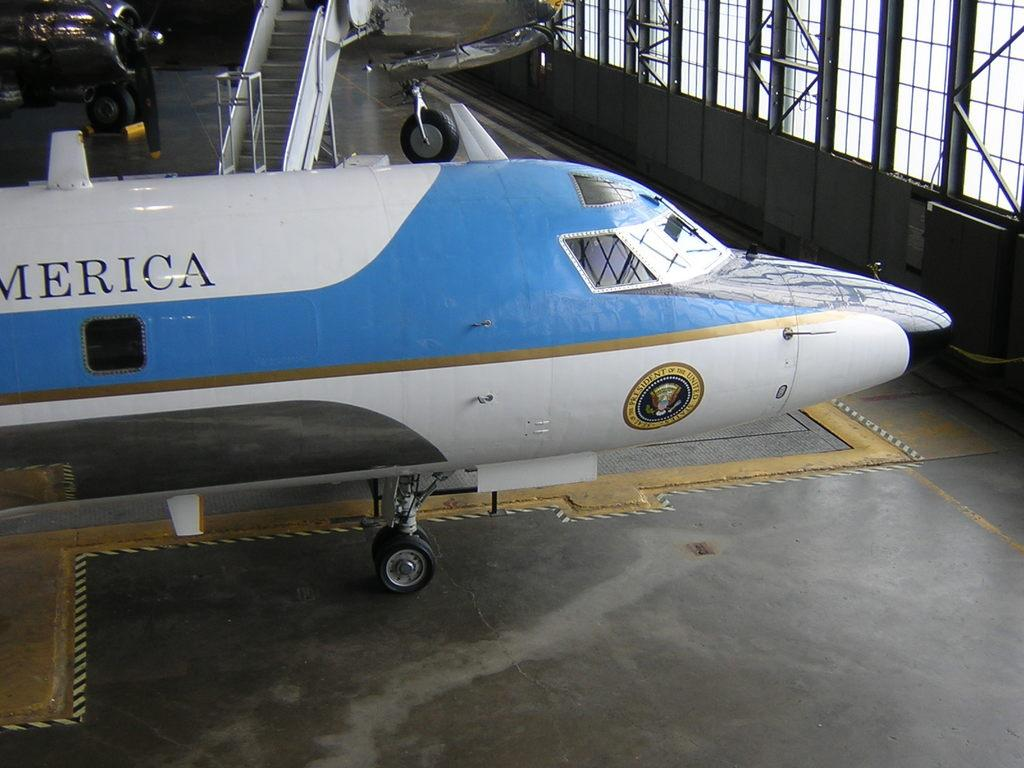<image>
Create a compact narrative representing the image presented. a plane that has a president logo on the bottom of it 